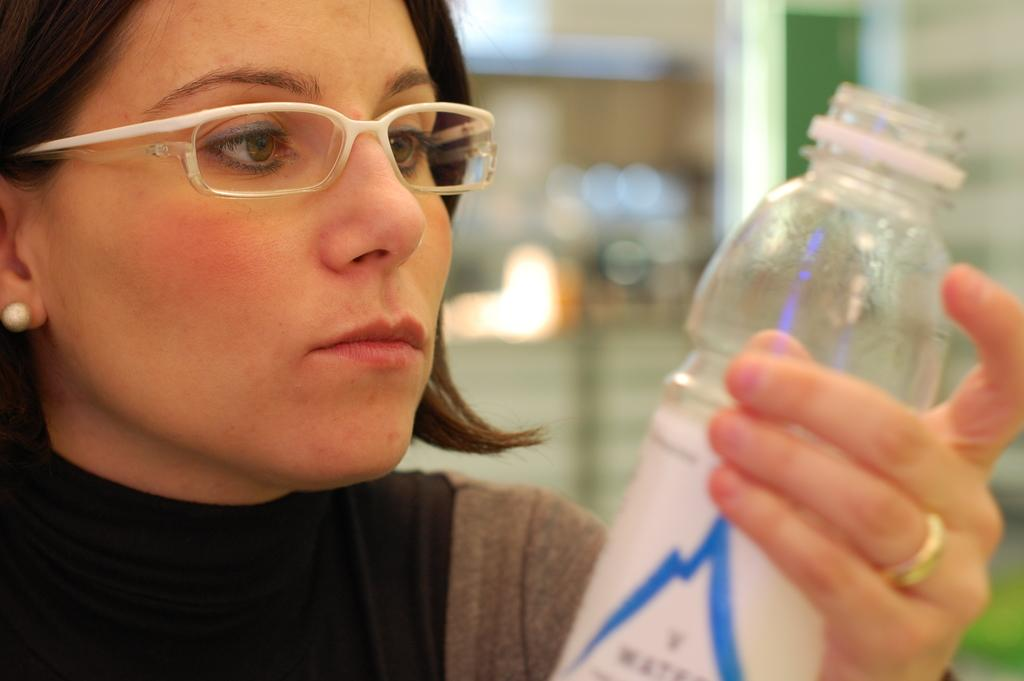Who is the main subject in the picture? There is a woman in the picture. What is the woman wearing in the image? The woman is wearing spectacles. What object is the woman holding in the image? The woman is holding a water bottle in her hands. How many men are present in the image? There are no men present in the image; it features a woman. What type of glue is the woman using in the image? There is no glue present in the image; the woman is holding a water bottle. 